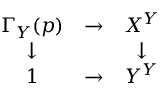<formula> <loc_0><loc_0><loc_500><loc_500>\begin{array} { c c c } { \Gamma _ { Y } ( p ) } & { \to } & { X ^ { Y } } \\ { \downarrow } & { \downarrow } \\ { 1 } & { \to } & { Y ^ { Y } } \end{array}</formula> 